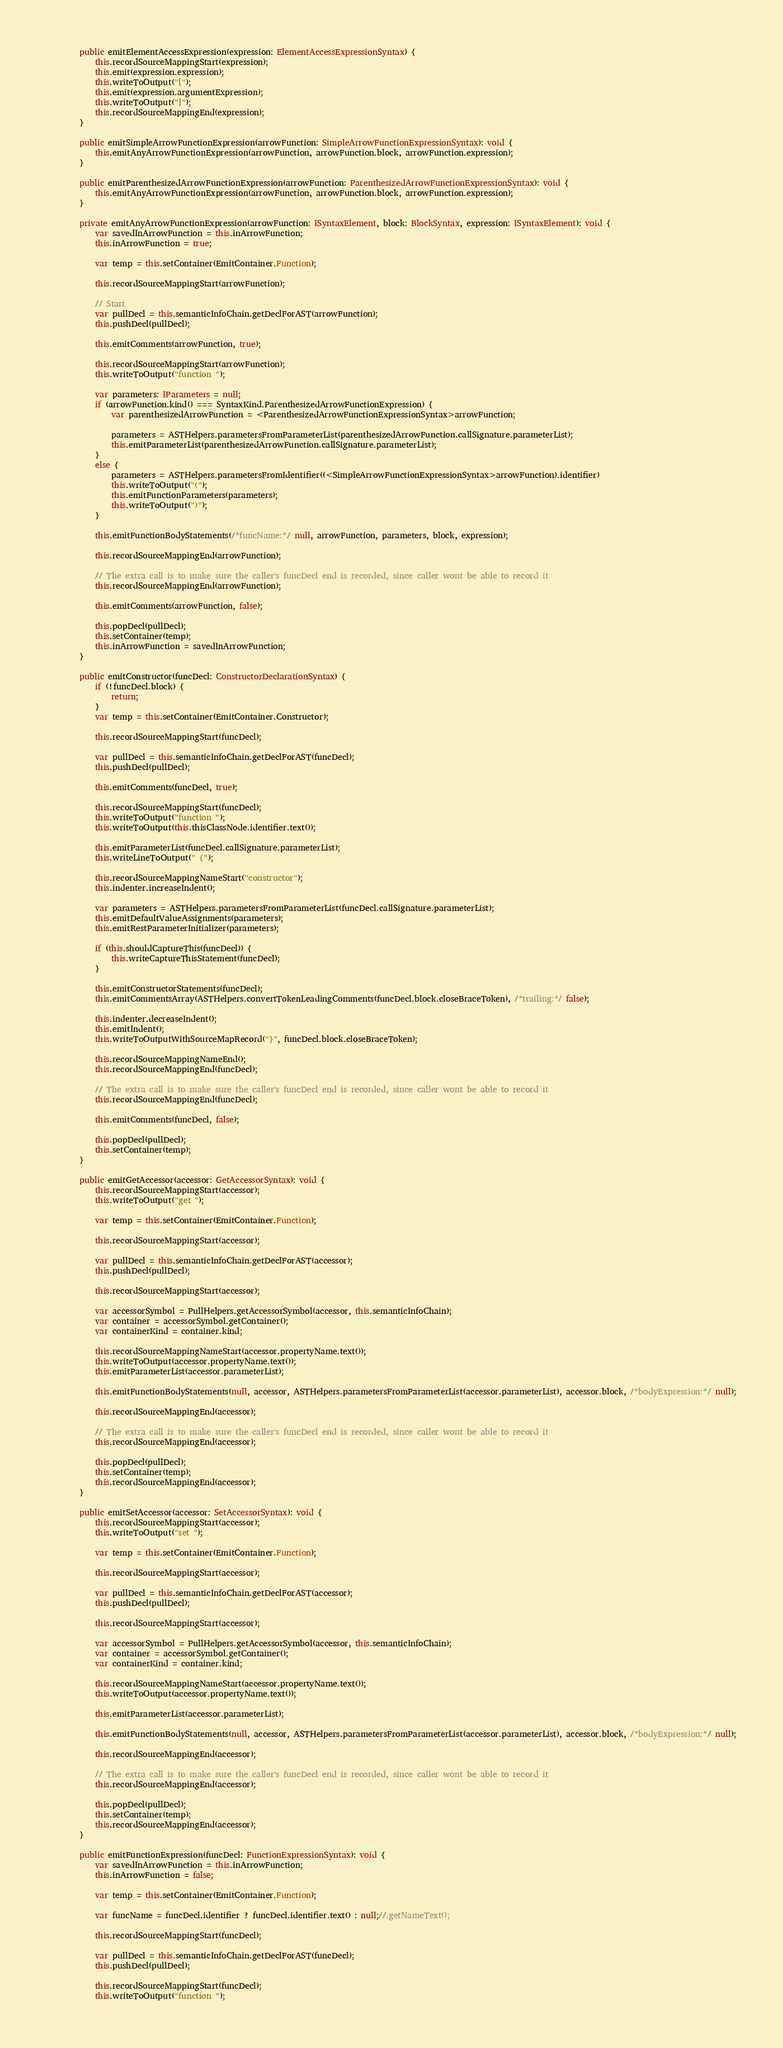<code> <loc_0><loc_0><loc_500><loc_500><_TypeScript_>
        public emitElementAccessExpression(expression: ElementAccessExpressionSyntax) {
            this.recordSourceMappingStart(expression);
            this.emit(expression.expression);
            this.writeToOutput("[");
            this.emit(expression.argumentExpression);
            this.writeToOutput("]");
            this.recordSourceMappingEnd(expression);
        }

        public emitSimpleArrowFunctionExpression(arrowFunction: SimpleArrowFunctionExpressionSyntax): void {
            this.emitAnyArrowFunctionExpression(arrowFunction, arrowFunction.block, arrowFunction.expression);
        }

        public emitParenthesizedArrowFunctionExpression(arrowFunction: ParenthesizedArrowFunctionExpressionSyntax): void {
            this.emitAnyArrowFunctionExpression(arrowFunction, arrowFunction.block, arrowFunction.expression);
        }

        private emitAnyArrowFunctionExpression(arrowFunction: ISyntaxElement, block: BlockSyntax, expression: ISyntaxElement): void {
            var savedInArrowFunction = this.inArrowFunction;
            this.inArrowFunction = true;

            var temp = this.setContainer(EmitContainer.Function);

            this.recordSourceMappingStart(arrowFunction);

            // Start
            var pullDecl = this.semanticInfoChain.getDeclForAST(arrowFunction);
            this.pushDecl(pullDecl);

            this.emitComments(arrowFunction, true);

            this.recordSourceMappingStart(arrowFunction);
            this.writeToOutput("function ");

            var parameters: IParameters = null;
            if (arrowFunction.kind() === SyntaxKind.ParenthesizedArrowFunctionExpression) {
                var parenthesizedArrowFunction = <ParenthesizedArrowFunctionExpressionSyntax>arrowFunction;

                parameters = ASTHelpers.parametersFromParameterList(parenthesizedArrowFunction.callSignature.parameterList);
                this.emitParameterList(parenthesizedArrowFunction.callSignature.parameterList);
            }
            else {
                parameters = ASTHelpers.parametersFromIdentifier((<SimpleArrowFunctionExpressionSyntax>arrowFunction).identifier)
                this.writeToOutput("(");
                this.emitFunctionParameters(parameters);
                this.writeToOutput(")");
            }

            this.emitFunctionBodyStatements(/*funcName:*/ null, arrowFunction, parameters, block, expression);

            this.recordSourceMappingEnd(arrowFunction);

            // The extra call is to make sure the caller's funcDecl end is recorded, since caller wont be able to record it
            this.recordSourceMappingEnd(arrowFunction);

            this.emitComments(arrowFunction, false);

            this.popDecl(pullDecl);
            this.setContainer(temp);
            this.inArrowFunction = savedInArrowFunction;
        }

        public emitConstructor(funcDecl: ConstructorDeclarationSyntax) {
            if (!funcDecl.block) {
                return;
            }
            var temp = this.setContainer(EmitContainer.Constructor);

            this.recordSourceMappingStart(funcDecl);

            var pullDecl = this.semanticInfoChain.getDeclForAST(funcDecl);
            this.pushDecl(pullDecl);

            this.emitComments(funcDecl, true);

            this.recordSourceMappingStart(funcDecl);
            this.writeToOutput("function ");
            this.writeToOutput(this.thisClassNode.identifier.text());

            this.emitParameterList(funcDecl.callSignature.parameterList);
            this.writeLineToOutput(" {");

            this.recordSourceMappingNameStart("constructor");
            this.indenter.increaseIndent();

            var parameters = ASTHelpers.parametersFromParameterList(funcDecl.callSignature.parameterList);
            this.emitDefaultValueAssignments(parameters);
            this.emitRestParameterInitializer(parameters);

            if (this.shouldCaptureThis(funcDecl)) {
                this.writeCaptureThisStatement(funcDecl);
            }

            this.emitConstructorStatements(funcDecl);
            this.emitCommentsArray(ASTHelpers.convertTokenLeadingComments(funcDecl.block.closeBraceToken), /*trailing:*/ false);

            this.indenter.decreaseIndent();
            this.emitIndent();
            this.writeToOutputWithSourceMapRecord("}", funcDecl.block.closeBraceToken);

            this.recordSourceMappingNameEnd();
            this.recordSourceMappingEnd(funcDecl);

            // The extra call is to make sure the caller's funcDecl end is recorded, since caller wont be able to record it
            this.recordSourceMappingEnd(funcDecl);

            this.emitComments(funcDecl, false);

            this.popDecl(pullDecl);
            this.setContainer(temp);
        }

        public emitGetAccessor(accessor: GetAccessorSyntax): void {
            this.recordSourceMappingStart(accessor);
            this.writeToOutput("get ");

            var temp = this.setContainer(EmitContainer.Function);

            this.recordSourceMappingStart(accessor);

            var pullDecl = this.semanticInfoChain.getDeclForAST(accessor);
            this.pushDecl(pullDecl);

            this.recordSourceMappingStart(accessor);

            var accessorSymbol = PullHelpers.getAccessorSymbol(accessor, this.semanticInfoChain);
            var container = accessorSymbol.getContainer();
            var containerKind = container.kind;

            this.recordSourceMappingNameStart(accessor.propertyName.text());
            this.writeToOutput(accessor.propertyName.text());
            this.emitParameterList(accessor.parameterList);

            this.emitFunctionBodyStatements(null, accessor, ASTHelpers.parametersFromParameterList(accessor.parameterList), accessor.block, /*bodyExpression:*/ null);

            this.recordSourceMappingEnd(accessor);

            // The extra call is to make sure the caller's funcDecl end is recorded, since caller wont be able to record it
            this.recordSourceMappingEnd(accessor);

            this.popDecl(pullDecl);
            this.setContainer(temp);
            this.recordSourceMappingEnd(accessor);
        }

        public emitSetAccessor(accessor: SetAccessorSyntax): void {
            this.recordSourceMappingStart(accessor);
            this.writeToOutput("set ");

            var temp = this.setContainer(EmitContainer.Function);

            this.recordSourceMappingStart(accessor);

            var pullDecl = this.semanticInfoChain.getDeclForAST(accessor);
            this.pushDecl(pullDecl);

            this.recordSourceMappingStart(accessor);

            var accessorSymbol = PullHelpers.getAccessorSymbol(accessor, this.semanticInfoChain);
            var container = accessorSymbol.getContainer();
            var containerKind = container.kind;

            this.recordSourceMappingNameStart(accessor.propertyName.text());
            this.writeToOutput(accessor.propertyName.text());

            this.emitParameterList(accessor.parameterList);

            this.emitFunctionBodyStatements(null, accessor, ASTHelpers.parametersFromParameterList(accessor.parameterList), accessor.block, /*bodyExpression:*/ null);

            this.recordSourceMappingEnd(accessor);

            // The extra call is to make sure the caller's funcDecl end is recorded, since caller wont be able to record it
            this.recordSourceMappingEnd(accessor);

            this.popDecl(pullDecl);
            this.setContainer(temp);
            this.recordSourceMappingEnd(accessor);
        }

        public emitFunctionExpression(funcDecl: FunctionExpressionSyntax): void {
            var savedInArrowFunction = this.inArrowFunction;
            this.inArrowFunction = false;

            var temp = this.setContainer(EmitContainer.Function);

            var funcName = funcDecl.identifier ? funcDecl.identifier.text() : null;//.getNameText();

            this.recordSourceMappingStart(funcDecl);

            var pullDecl = this.semanticInfoChain.getDeclForAST(funcDecl);
            this.pushDecl(pullDecl);

            this.recordSourceMappingStart(funcDecl);
            this.writeToOutput("function ");
</code> 